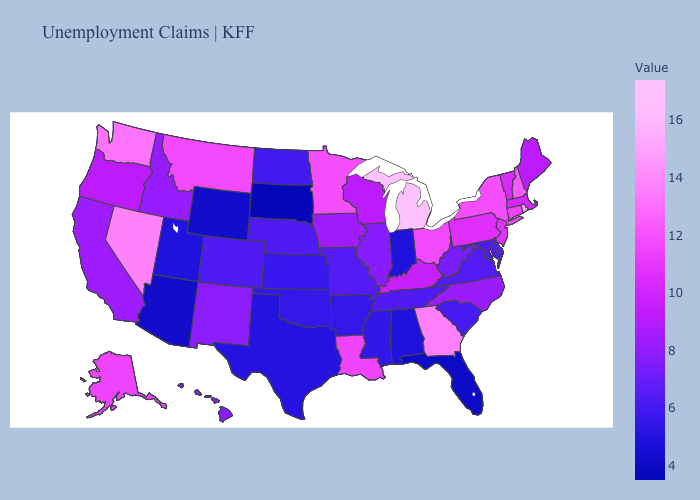Among the states that border Delaware , which have the highest value?
Write a very short answer. New Jersey. Does Michigan have the highest value in the USA?
Write a very short answer. Yes. Among the states that border Alabama , does Florida have the highest value?
Short answer required. No. Is the legend a continuous bar?
Give a very brief answer. Yes. 